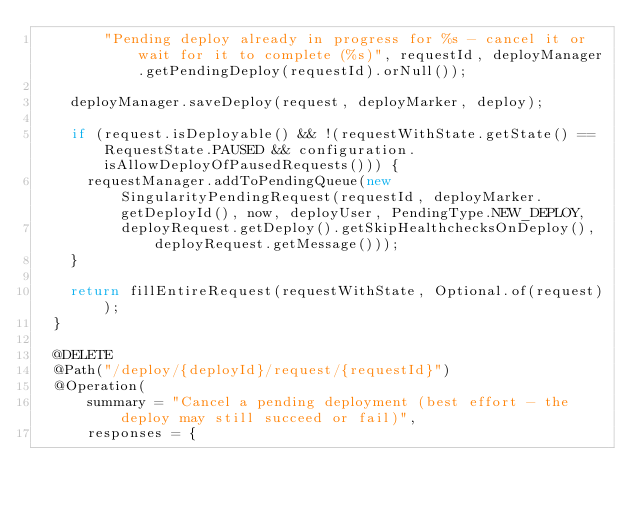<code> <loc_0><loc_0><loc_500><loc_500><_Java_>        "Pending deploy already in progress for %s - cancel it or wait for it to complete (%s)", requestId, deployManager.getPendingDeploy(requestId).orNull());

    deployManager.saveDeploy(request, deployMarker, deploy);

    if (request.isDeployable() && !(requestWithState.getState() == RequestState.PAUSED && configuration.isAllowDeployOfPausedRequests())) {
      requestManager.addToPendingQueue(new SingularityPendingRequest(requestId, deployMarker.getDeployId(), now, deployUser, PendingType.NEW_DEPLOY,
          deployRequest.getDeploy().getSkipHealthchecksOnDeploy(), deployRequest.getMessage()));
    }

    return fillEntireRequest(requestWithState, Optional.of(request));
  }

  @DELETE
  @Path("/deploy/{deployId}/request/{requestId}")
  @Operation(
      summary = "Cancel a pending deployment (best effort - the deploy may still succeed or fail)",
      responses = {</code> 